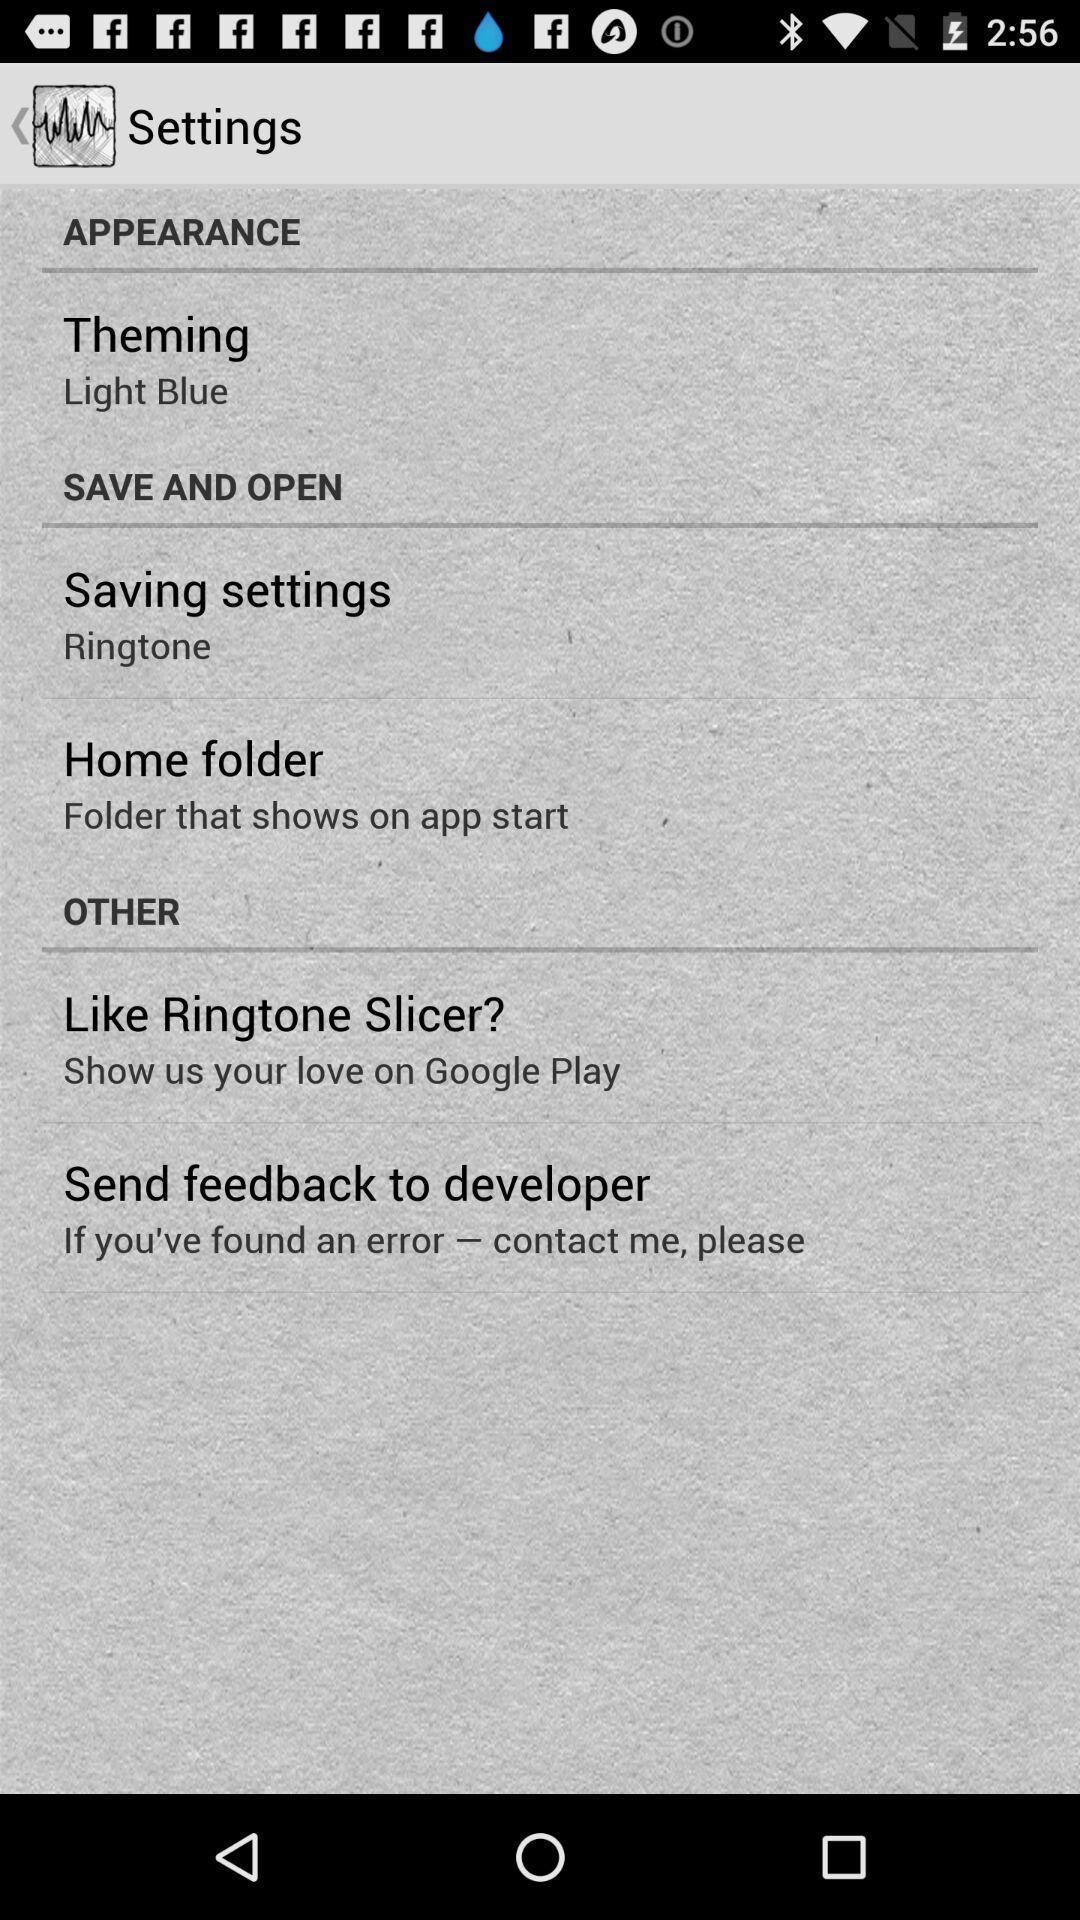Give me a summary of this screen capture. Settings page displaying in application. 